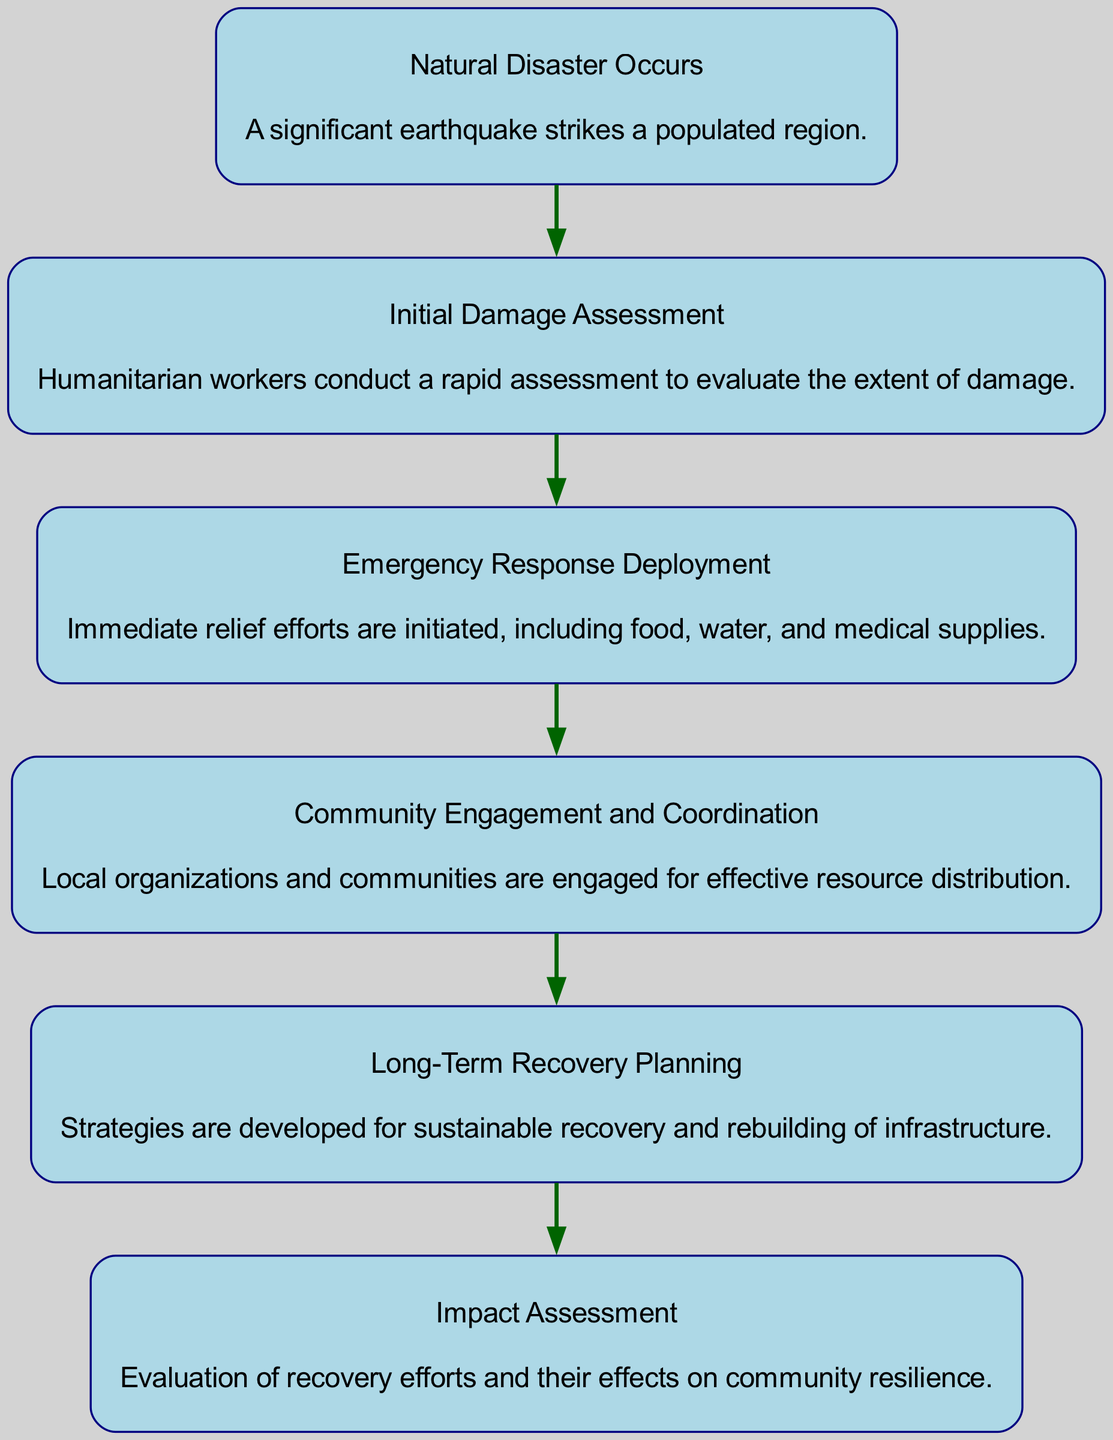What is the first step in the timeline of relief efforts? The first step in the timeline is represented by the node labeled "Natural Disaster Occurs," indicating that the sequence begins with the occurrence of a significant earthquake.
Answer: Natural Disaster Occurs How many nodes are present in the diagram? Counting the nodes visually in the diagram, there are six distinct nodes, each representing a different phase of the relief efforts.
Answer: 6 What is the last step in the recovery process according to the diagram? The last step in the recovery process is the "Impact Assessment," which evaluates the outcomes of prior recovery efforts and their impact on community resilience.
Answer: Impact Assessment Which node follows "Initial Damage Assessment"? The node that follows "Initial Damage Assessment" is "Emergency Response Deployment." This shows the immediate action taken after the initial assessment.
Answer: Emergency Response Deployment How many edges are connecting the nodes in the diagram? The diagram includes five edges, as they represent the directed relationships between each phase of the timeline of relief efforts.
Answer: 5 What is the relationship between "Community Engagement and Coordination" and "Long-Term Recovery Planning"? The relationship shows that "Community Engagement and Coordination" leads into "Long-Term Recovery Planning," meaning community involvement is integral to planning for the future recovery.
Answer: Long-Term Recovery Planning During which phase are local organizations engaged for effective resource distribution? Local organizations are engaged during the "Community Engagement and Coordination" phase, ensuring that distributed resources are managed correctly and efficiently.
Answer: Community Engagement and Coordination What is the purpose of the "Long-Term Recovery Planning" phase? The purpose is to develop strategies for sustainable recovery and rebuilding critical infrastructure in the affected community.
Answer: Sustainable recovery and rebuilding What is the connection between "Emergency Response Deployment" and "Community Engagement"? The connection indicates that after emergency responses have been deployed, there is a need for active engagement with communities to ensure that the resources are effectively utilized and distributed.
Answer: Active engagement with communities 